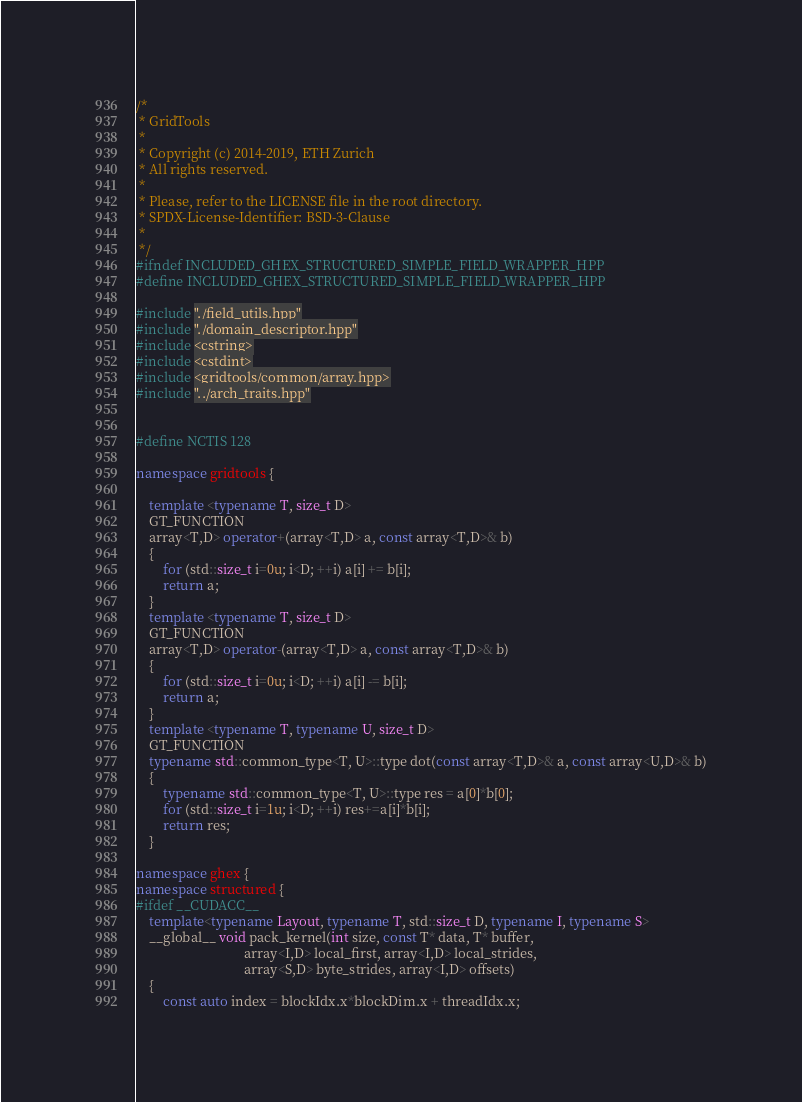Convert code to text. <code><loc_0><loc_0><loc_500><loc_500><_C++_>/* 
 * GridTools
 * 
 * Copyright (c) 2014-2019, ETH Zurich
 * All rights reserved.
 * 
 * Please, refer to the LICENSE file in the root directory.
 * SPDX-License-Identifier: BSD-3-Clause
 * 
 */
#ifndef INCLUDED_GHEX_STRUCTURED_SIMPLE_FIELD_WRAPPER_HPP
#define INCLUDED_GHEX_STRUCTURED_SIMPLE_FIELD_WRAPPER_HPP

#include "./field_utils.hpp"
#include "./domain_descriptor.hpp"
#include <cstring>
#include <cstdint>
#include <gridtools/common/array.hpp>
#include "../arch_traits.hpp"


#define NCTIS 128

namespace gridtools {

    template <typename T, size_t D>
    GT_FUNCTION
    array<T,D> operator+(array<T,D> a, const array<T,D>& b)
    {
        for (std::size_t i=0u; i<D; ++i) a[i] += b[i];
        return a;
    }
    template <typename T, size_t D>
    GT_FUNCTION
    array<T,D> operator-(array<T,D> a, const array<T,D>& b)
    {
        for (std::size_t i=0u; i<D; ++i) a[i] -= b[i];
        return a;
    }
    template <typename T, typename U, size_t D>
    GT_FUNCTION
    typename std::common_type<T, U>::type dot(const array<T,D>& a, const array<U,D>& b)
    {
        typename std::common_type<T, U>::type res = a[0]*b[0];
        for (std::size_t i=1u; i<D; ++i) res+=a[i]*b[i];
        return res;
    }

namespace ghex {
namespace structured {    
#ifdef __CUDACC__
    template<typename Layout, typename T, std::size_t D, typename I, typename S>
    __global__ void pack_kernel(int size, const T* data, T* buffer, 
                                array<I,D> local_first, array<I,D> local_strides,
                                array<S,D> byte_strides, array<I,D> offsets)
    {
        const auto index = blockIdx.x*blockDim.x + threadIdx.x;</code> 